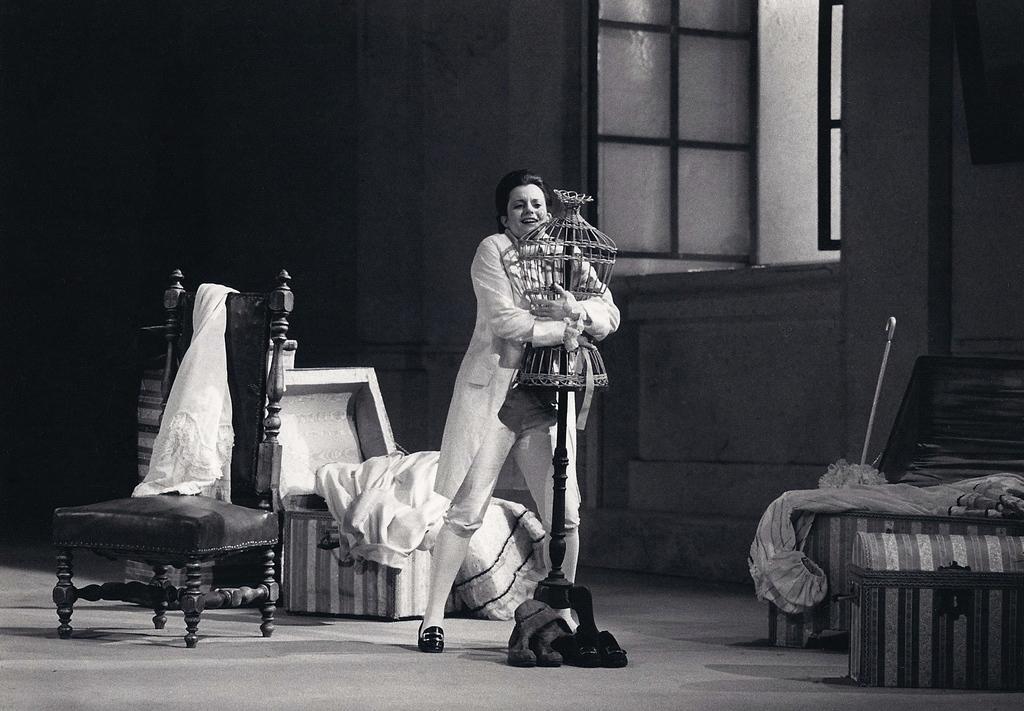How would you summarize this image in a sentence or two? In the picture I can see a woman is standing on the floor. In the background I can see clothes, a box, a chair, wall, a window and some other objects. This picture is black and white in color. 